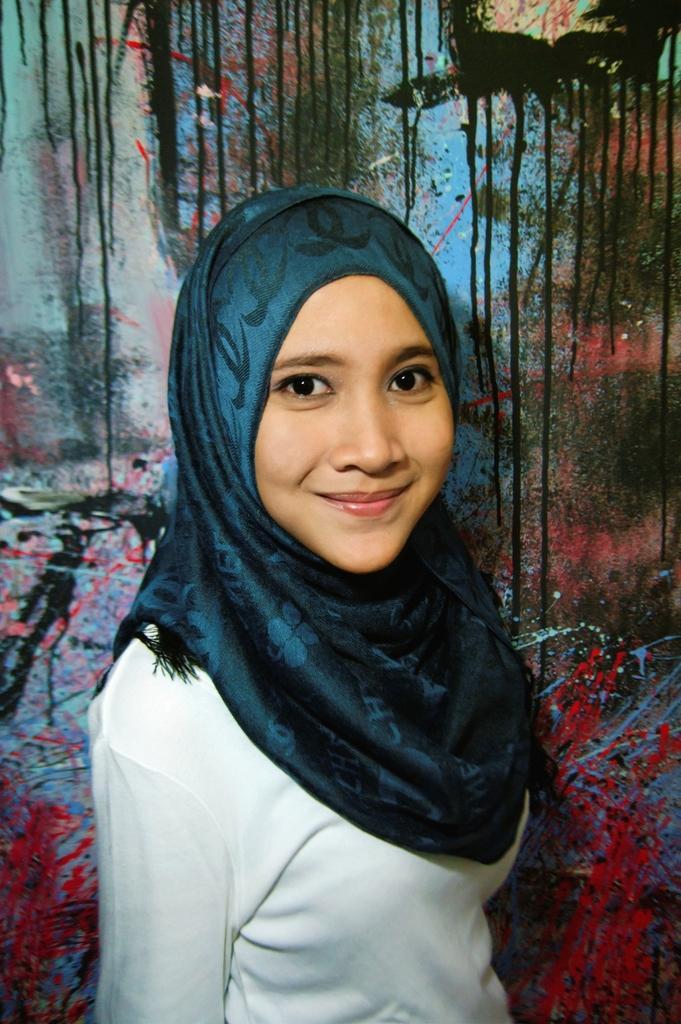In one or two sentences, can you explain what this image depicts? In the image we can see a girl wearing clothes, this is a scarf and there is a painting on the wall. 